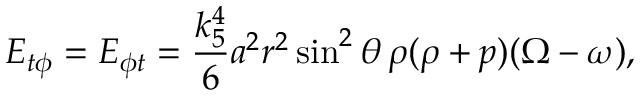Convert formula to latex. <formula><loc_0><loc_0><loc_500><loc_500>E _ { t \phi } = E _ { \phi t } = \frac { k _ { 5 } ^ { 4 } } 6 a ^ { 2 } r ^ { 2 } \sin ^ { 2 } \theta \, \rho ( \rho + p ) ( \Omega - \omega ) ,</formula> 